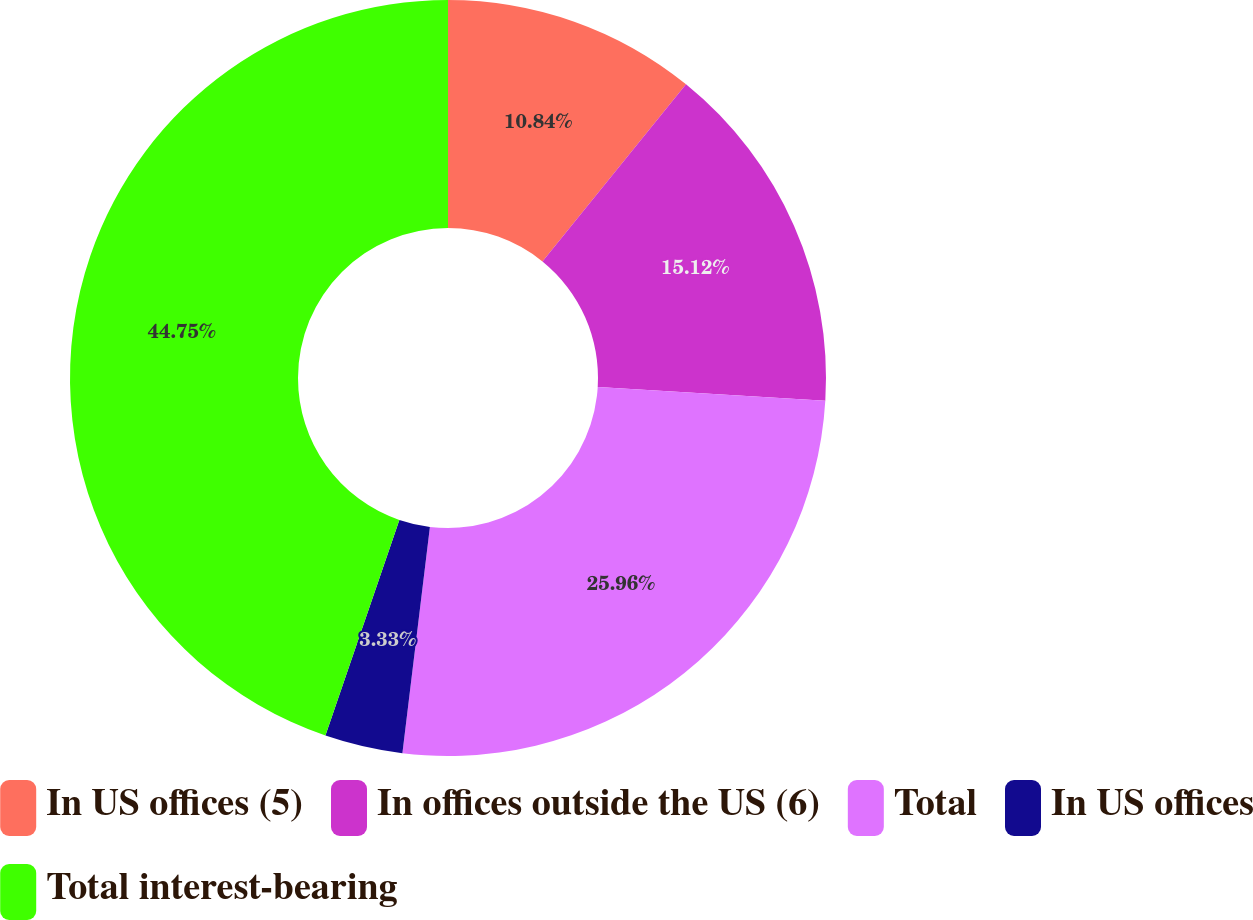<chart> <loc_0><loc_0><loc_500><loc_500><pie_chart><fcel>In US offices (5)<fcel>In offices outside the US (6)<fcel>Total<fcel>In US offices<fcel>Total interest-bearing<nl><fcel>10.84%<fcel>15.12%<fcel>25.96%<fcel>3.33%<fcel>44.74%<nl></chart> 